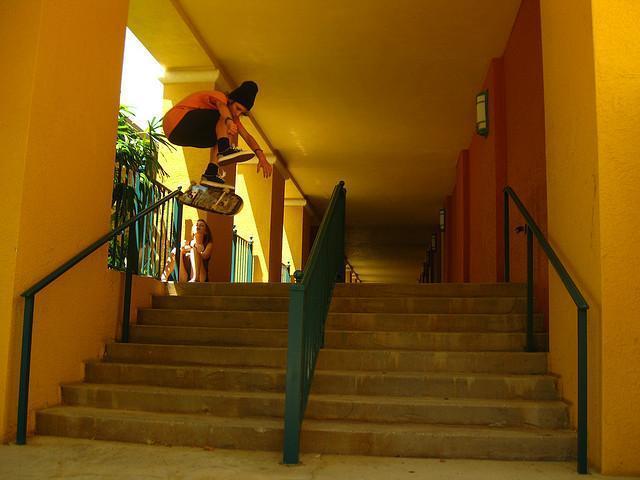How many people are there?
Give a very brief answer. 2. 